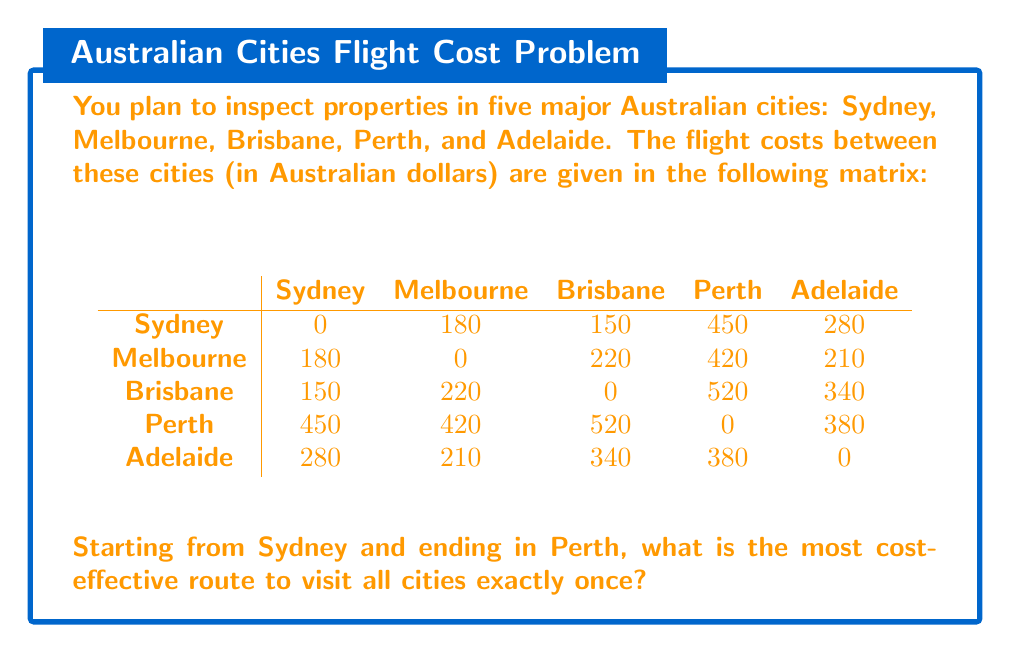What is the answer to this math problem? To solve this problem, we need to find the shortest Hamiltonian path from Sydney to Perth that visits all other cities exactly once. This is a variation of the Traveling Salesman Problem.

Given the small number of cities, we can solve this using a brute-force approach by examining all possible routes:

1. Sydney → Melbourne → Brisbane → Adelaide → Perth
2. Sydney → Melbourne → Adelaide → Brisbane → Perth
3. Sydney → Brisbane → Melbourne → Adelaide → Perth
4. Sydney → Brisbane → Adelaide → Melbourne → Perth
5. Sydney → Adelaide → Melbourne → Brisbane → Perth
6. Sydney → Adelaide → Brisbane → Melbourne → Perth

Let's calculate the cost for each route:

1. $180 + 220 + 340 + 380 = 1120$
2. $180 + 210 + 340 + 520 = 1250$
3. $150 + 220 + 210 + 420 = 1000$
4. $150 + 340 + 210 + 420 = 1120$
5. $280 + 180 + 220 + 420 = 1100$
6. $280 + 340 + 220 + 420 = 1260$

The most cost-effective route is option 3: Sydney → Brisbane → Melbourne → Adelaide → Perth, with a total cost of $1000.
Answer: The most cost-effective route is Sydney → Brisbane → Melbourne → Adelaide → Perth, with a total cost of $1000 AUD. 